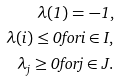<formula> <loc_0><loc_0><loc_500><loc_500>\lambda ( 1 ) = - 1 , \\ \lambda ( i ) \leq 0 f o r i \in I , \\ \lambda _ { j } \geq 0 f o r j \in J .</formula> 